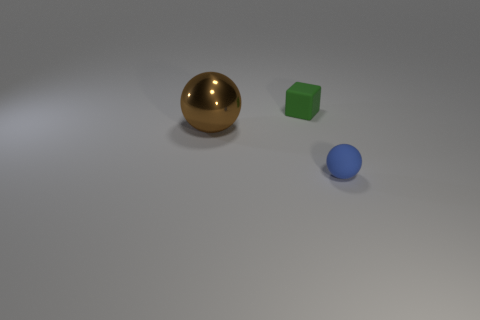Add 2 cyan objects. How many objects exist? 5 Subtract all blocks. How many objects are left? 2 Subtract 1 blue balls. How many objects are left? 2 Subtract all rubber cubes. Subtract all green matte objects. How many objects are left? 1 Add 2 small blue things. How many small blue things are left? 3 Add 2 big blocks. How many big blocks exist? 2 